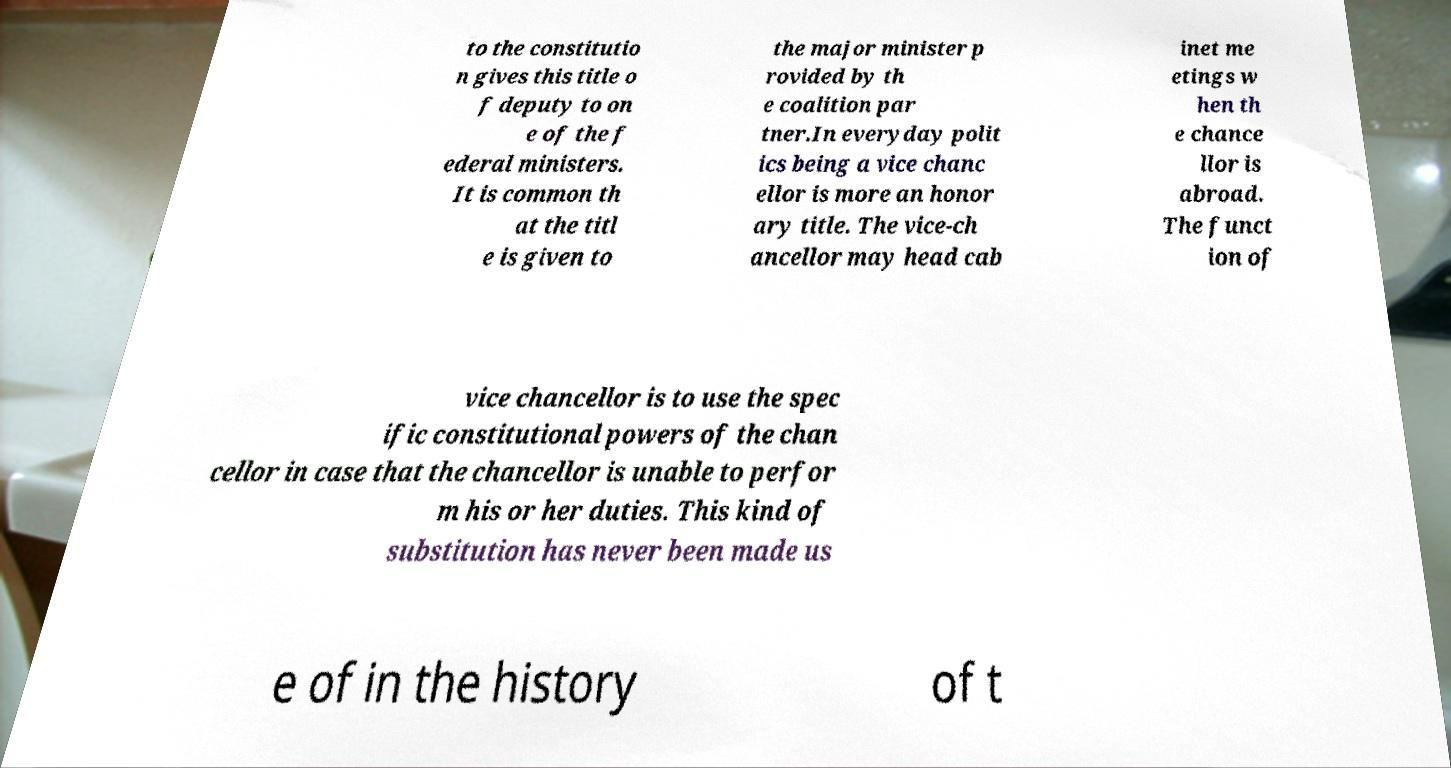I need the written content from this picture converted into text. Can you do that? to the constitutio n gives this title o f deputy to on e of the f ederal ministers. It is common th at the titl e is given to the major minister p rovided by th e coalition par tner.In everyday polit ics being a vice chanc ellor is more an honor ary title. The vice-ch ancellor may head cab inet me etings w hen th e chance llor is abroad. The funct ion of vice chancellor is to use the spec ific constitutional powers of the chan cellor in case that the chancellor is unable to perfor m his or her duties. This kind of substitution has never been made us e of in the history of t 